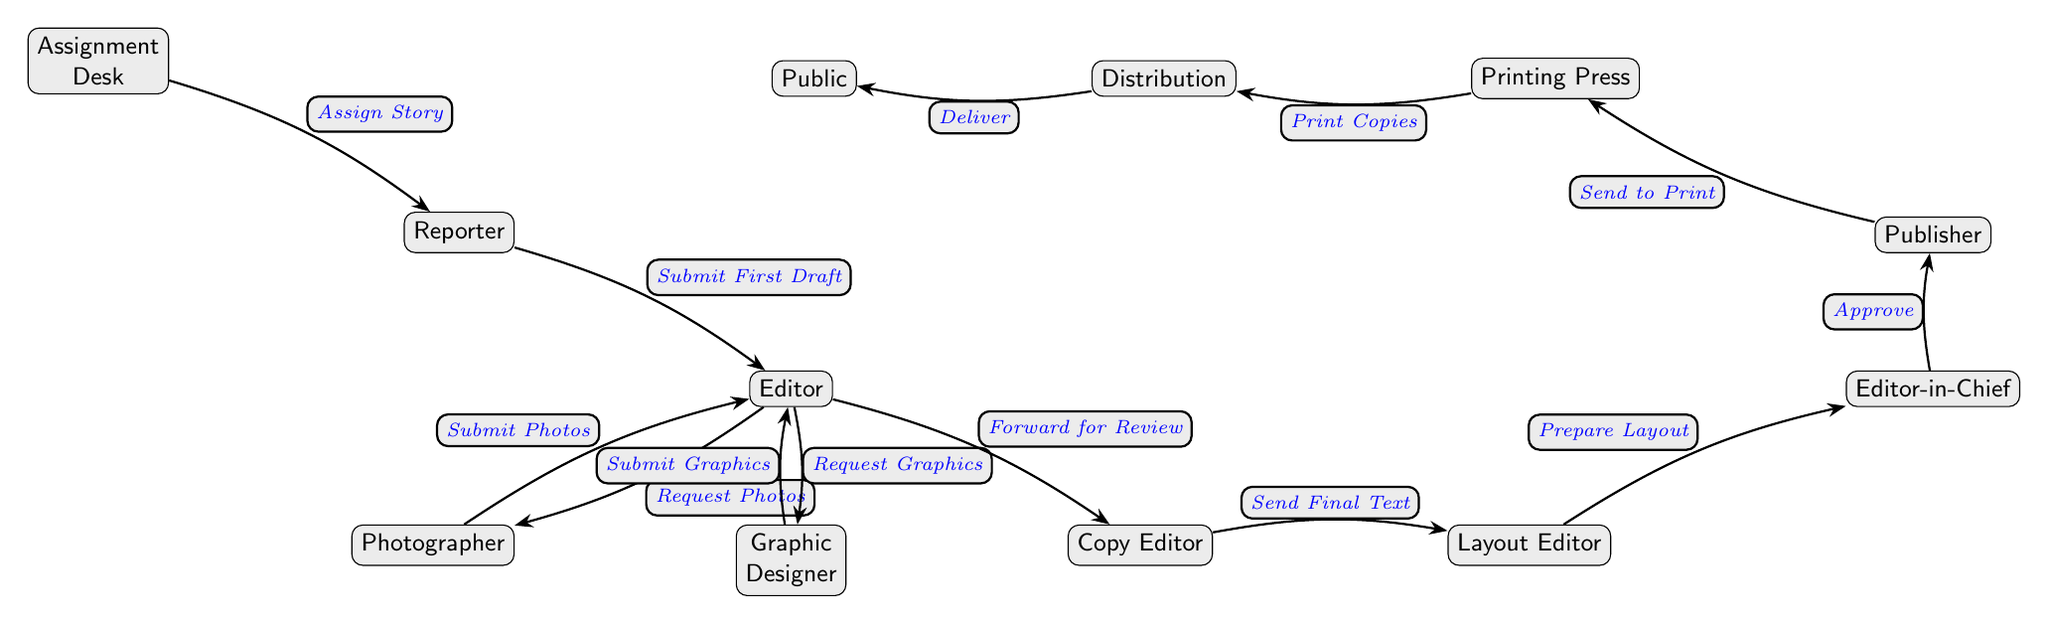What is the first step in the publication process? The diagram indicates that the first step in the publication process is "Assignment Desk," which assigns the story to a reporter.
Answer: Assignment Desk How many roles are involved in the newspaper structure diagram? Counting all the nodes in the diagram, there are a total of 9 roles, which include Assignment Desk, Reporter, Editor, Photographer, Graphic Designer, Copy Editor, Layout Editor, Editor-in-Chief, and Publisher.
Answer: 9 Who does the reporter submit the first draft to? From the diagram, the reporter submits the first draft to the Editor. This connection is shown by the arrow pointing from Reporter to Editor labeled "Submit First Draft."
Answer: Editor What is the last step before the publication reaches the public? The last step before the publication reaches the public is "Deliver," which comes after the copies are printed and distributed from the Printing Press. This is represented by the flow leading from Distribution to Public.
Answer: Deliver What role is responsible for approving the layout? The role responsible for approving the layout is the Editor-in-Chief, as indicated in the diagram with an arrow pointing from Layout Editor to Editor-in-Chief labeled "Prepare Layout."
Answer: Editor-in-Chief What request does the Editor make to the Photographer? The Editor requests photos from the Photographer, as indicated by the arrow from Editor to Photographer labeled "Request Photos."
Answer: Request Photos Which role follows the Copy Editor in the workflow? The role that follows the Copy Editor in the workflow is the Layout Editor, as indicated by the arrow connecting the two roles labeled "Send Final Text."
Answer: Layout Editor What is the connection between the Publisher and the Printing Press? The connection is that the Publisher sends the publication to print, as depicted by the arrow from Publisher to Printing Press labeled "Send to Print."
Answer: Send to Print What happens after the Graphics are submitted by the Graphic Designer? After the Graphics are submitted, they are sent to the Editor for review, as shown by the arrow from Graphic Designer to Editor labeled "Submit Graphics."
Answer: Submit Graphics 